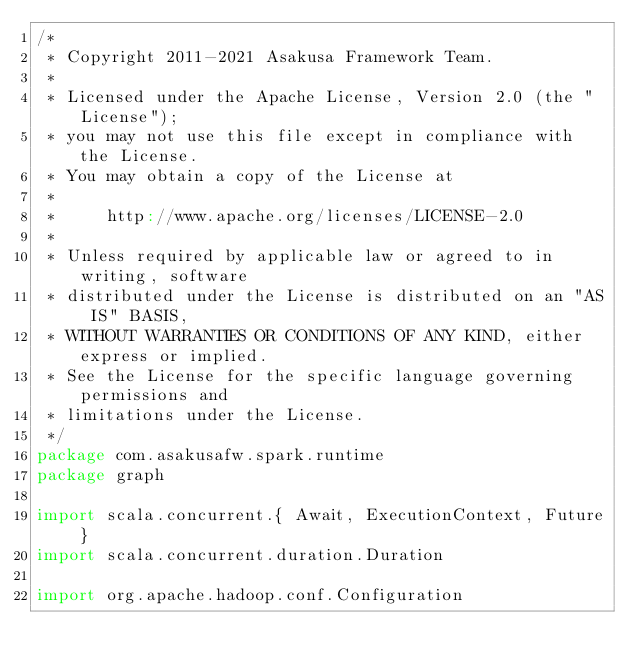<code> <loc_0><loc_0><loc_500><loc_500><_Scala_>/*
 * Copyright 2011-2021 Asakusa Framework Team.
 *
 * Licensed under the Apache License, Version 2.0 (the "License");
 * you may not use this file except in compliance with the License.
 * You may obtain a copy of the License at
 *
 *     http://www.apache.org/licenses/LICENSE-2.0
 *
 * Unless required by applicable law or agreed to in writing, software
 * distributed under the License is distributed on an "AS IS" BASIS,
 * WITHOUT WARRANTIES OR CONDITIONS OF ANY KIND, either express or implied.
 * See the License for the specific language governing permissions and
 * limitations under the License.
 */
package com.asakusafw.spark.runtime
package graph

import scala.concurrent.{ Await, ExecutionContext, Future }
import scala.concurrent.duration.Duration

import org.apache.hadoop.conf.Configuration</code> 